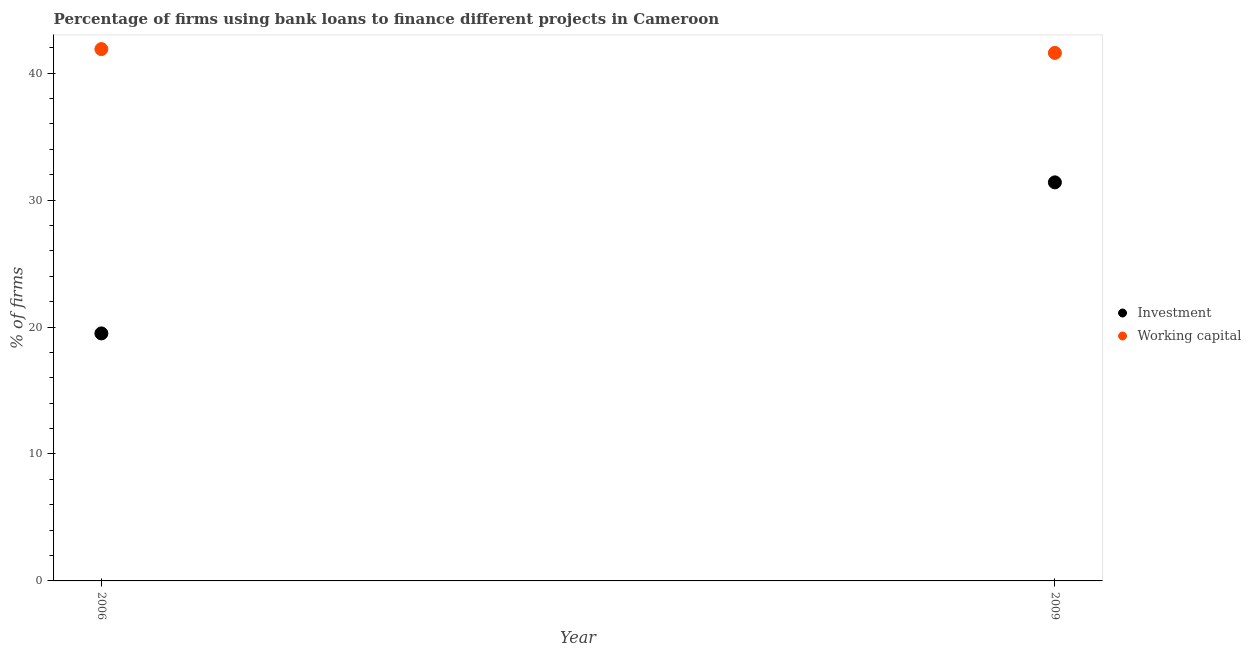What is the percentage of firms using banks to finance working capital in 2009?
Provide a short and direct response. 41.6. Across all years, what is the maximum percentage of firms using banks to finance investment?
Ensure brevity in your answer.  31.4. Across all years, what is the minimum percentage of firms using banks to finance working capital?
Offer a terse response. 41.6. What is the total percentage of firms using banks to finance investment in the graph?
Keep it short and to the point. 50.9. What is the difference between the percentage of firms using banks to finance working capital in 2006 and that in 2009?
Keep it short and to the point. 0.3. What is the difference between the percentage of firms using banks to finance working capital in 2006 and the percentage of firms using banks to finance investment in 2009?
Make the answer very short. 10.5. What is the average percentage of firms using banks to finance investment per year?
Give a very brief answer. 25.45. In the year 2006, what is the difference between the percentage of firms using banks to finance working capital and percentage of firms using banks to finance investment?
Offer a terse response. 22.4. In how many years, is the percentage of firms using banks to finance working capital greater than 30 %?
Keep it short and to the point. 2. What is the ratio of the percentage of firms using banks to finance investment in 2006 to that in 2009?
Give a very brief answer. 0.62. Is the percentage of firms using banks to finance investment in 2006 less than that in 2009?
Your answer should be compact. Yes. Does the percentage of firms using banks to finance working capital monotonically increase over the years?
Keep it short and to the point. No. Is the percentage of firms using banks to finance investment strictly greater than the percentage of firms using banks to finance working capital over the years?
Your answer should be very brief. No. Is the percentage of firms using banks to finance working capital strictly less than the percentage of firms using banks to finance investment over the years?
Provide a short and direct response. No. Are the values on the major ticks of Y-axis written in scientific E-notation?
Make the answer very short. No. Does the graph contain any zero values?
Keep it short and to the point. No. Does the graph contain grids?
Give a very brief answer. No. How many legend labels are there?
Give a very brief answer. 2. How are the legend labels stacked?
Your response must be concise. Vertical. What is the title of the graph?
Give a very brief answer. Percentage of firms using bank loans to finance different projects in Cameroon. Does "Savings" appear as one of the legend labels in the graph?
Your response must be concise. No. What is the label or title of the X-axis?
Your response must be concise. Year. What is the label or title of the Y-axis?
Your response must be concise. % of firms. What is the % of firms in Working capital in 2006?
Your answer should be compact. 41.9. What is the % of firms of Investment in 2009?
Ensure brevity in your answer.  31.4. What is the % of firms in Working capital in 2009?
Make the answer very short. 41.6. Across all years, what is the maximum % of firms of Investment?
Give a very brief answer. 31.4. Across all years, what is the maximum % of firms in Working capital?
Make the answer very short. 41.9. Across all years, what is the minimum % of firms in Working capital?
Make the answer very short. 41.6. What is the total % of firms of Investment in the graph?
Make the answer very short. 50.9. What is the total % of firms of Working capital in the graph?
Provide a short and direct response. 83.5. What is the difference between the % of firms of Investment in 2006 and that in 2009?
Provide a short and direct response. -11.9. What is the difference between the % of firms in Investment in 2006 and the % of firms in Working capital in 2009?
Your answer should be very brief. -22.1. What is the average % of firms of Investment per year?
Offer a very short reply. 25.45. What is the average % of firms of Working capital per year?
Make the answer very short. 41.75. In the year 2006, what is the difference between the % of firms in Investment and % of firms in Working capital?
Make the answer very short. -22.4. What is the ratio of the % of firms of Investment in 2006 to that in 2009?
Your answer should be compact. 0.62. What is the difference between the highest and the second highest % of firms in Working capital?
Keep it short and to the point. 0.3. What is the difference between the highest and the lowest % of firms of Working capital?
Offer a very short reply. 0.3. 